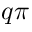<formula> <loc_0><loc_0><loc_500><loc_500>q \pi</formula> 